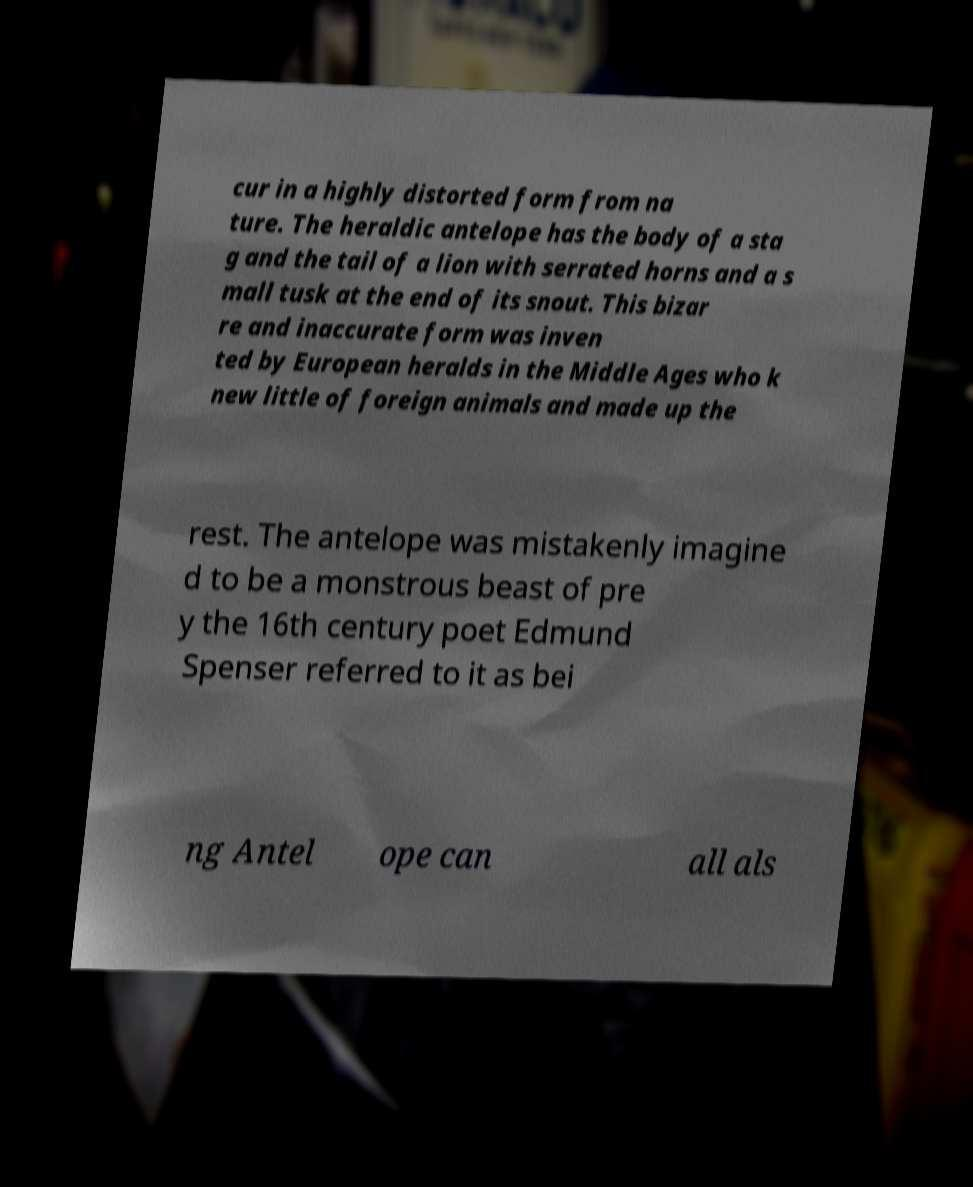I need the written content from this picture converted into text. Can you do that? cur in a highly distorted form from na ture. The heraldic antelope has the body of a sta g and the tail of a lion with serrated horns and a s mall tusk at the end of its snout. This bizar re and inaccurate form was inven ted by European heralds in the Middle Ages who k new little of foreign animals and made up the rest. The antelope was mistakenly imagine d to be a monstrous beast of pre y the 16th century poet Edmund Spenser referred to it as bei ng Antel ope can all als 